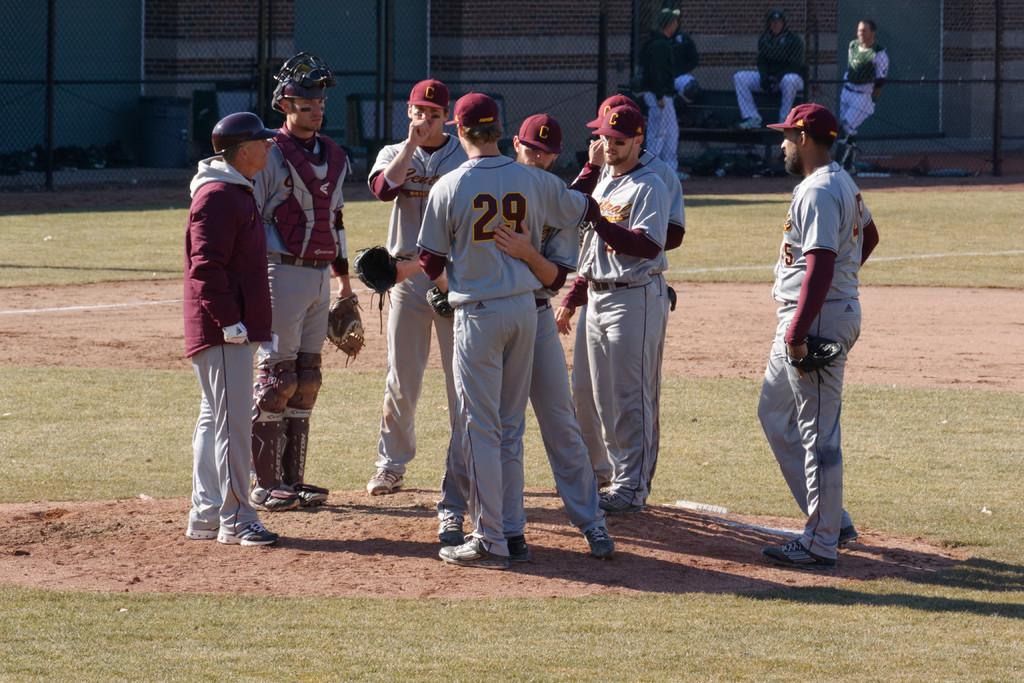What letter is on the teams cap?
Provide a succinct answer. C. 